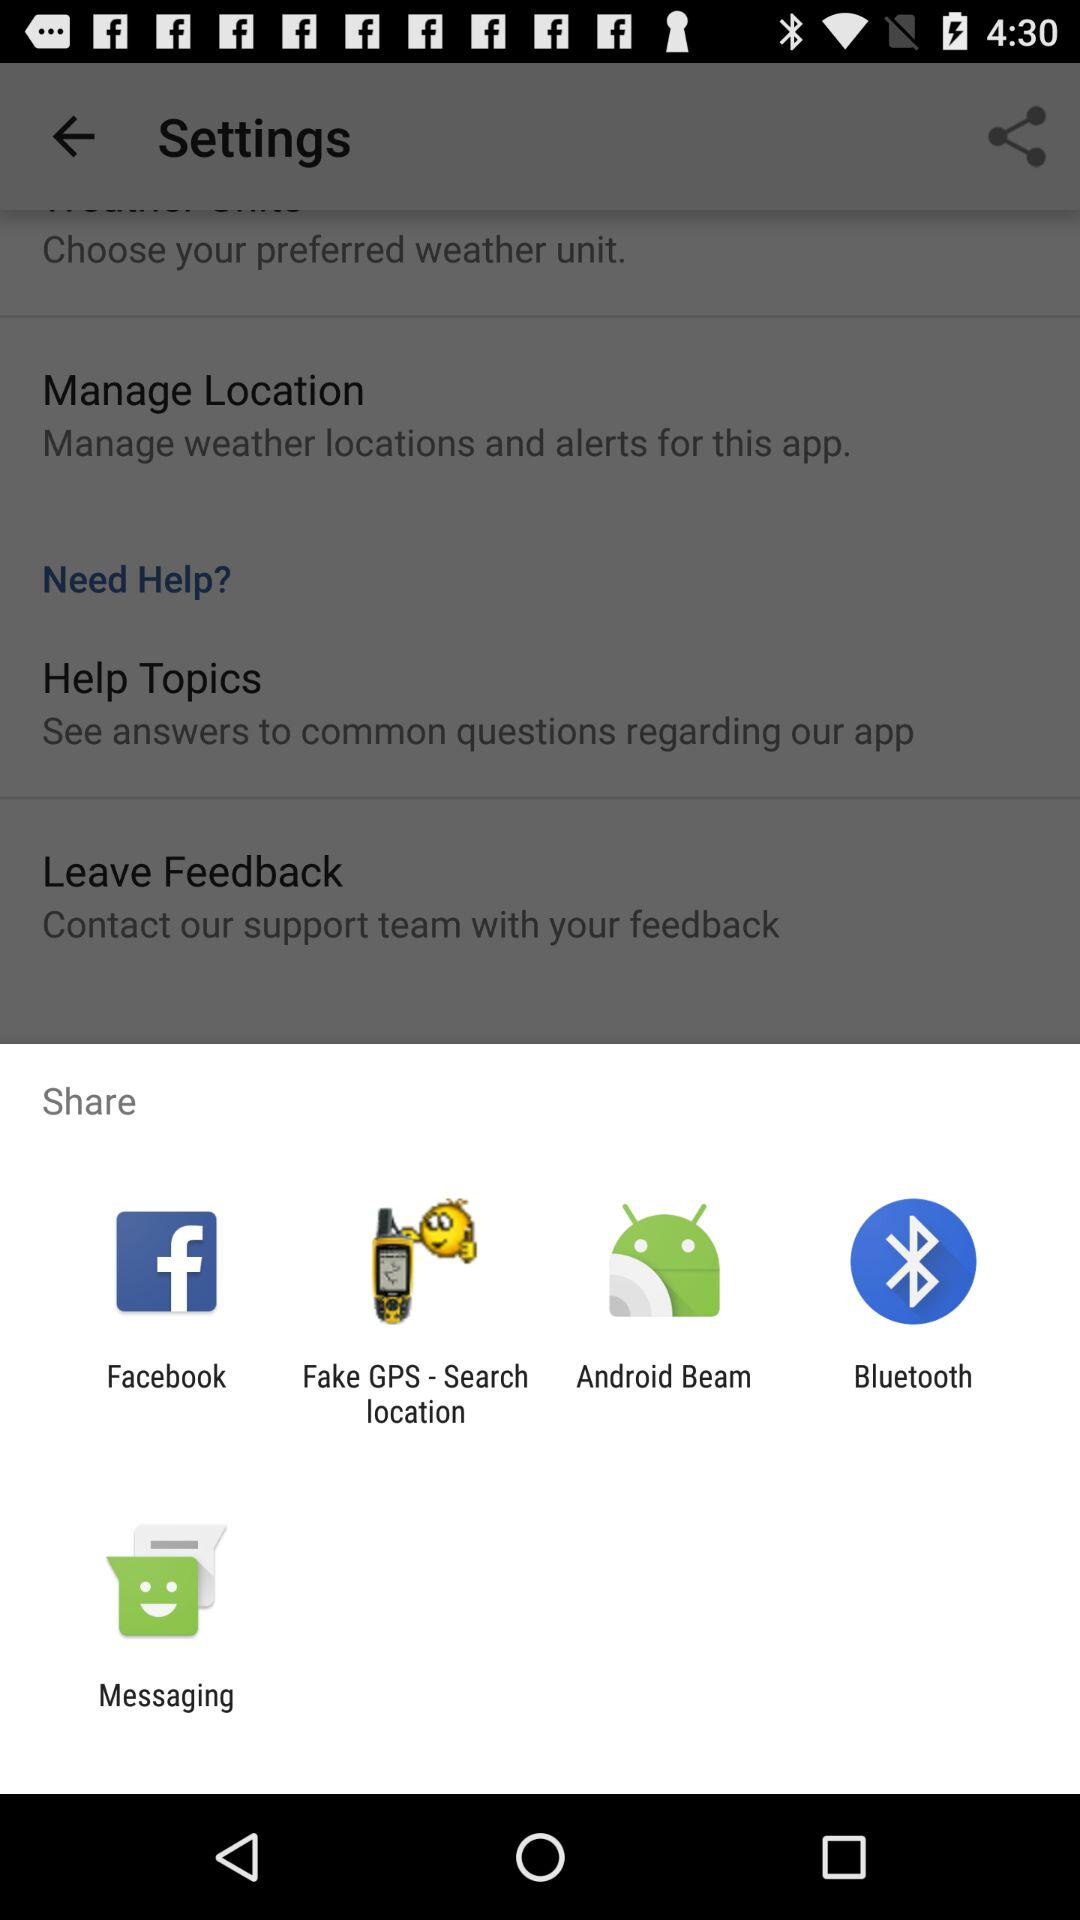Which applications can we use to share? You can use "Facebook", "Fake GPS - Search location", "Android Beam", "Bluetooth" and "Messaging". 